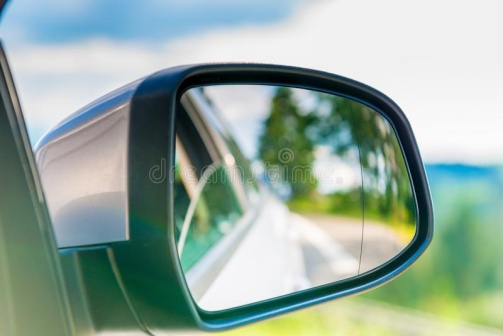What could be the destination that the road leads to in this mirror's reflection? The road reflected in the mirror appears to meander through a lush, green landscape, suggesting it might lead to a scenic area such as a park or nature reserve. The uninterrupted flow of the road and absence of any signs or vehicles hint at a less-traveled, peaceful route, perhaps leading to a secluded natural spot ideal for relaxation or recreation. 